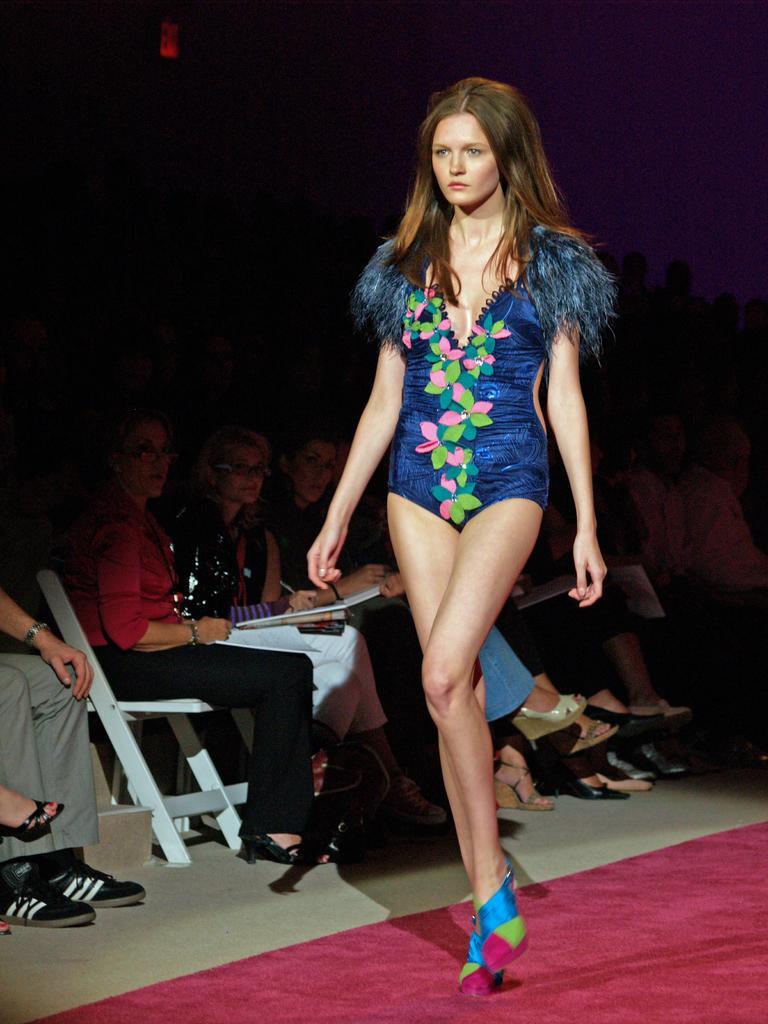Could you give a brief overview of what you see in this image? In this image there is a person walking, there are group of persons sitting, there are persons holding an object, there is a person truncated towards the left of the image, there is a carpet on the ground, there is a carpet truncated towards the right of the image, there is a light, the background of the image is dark. 